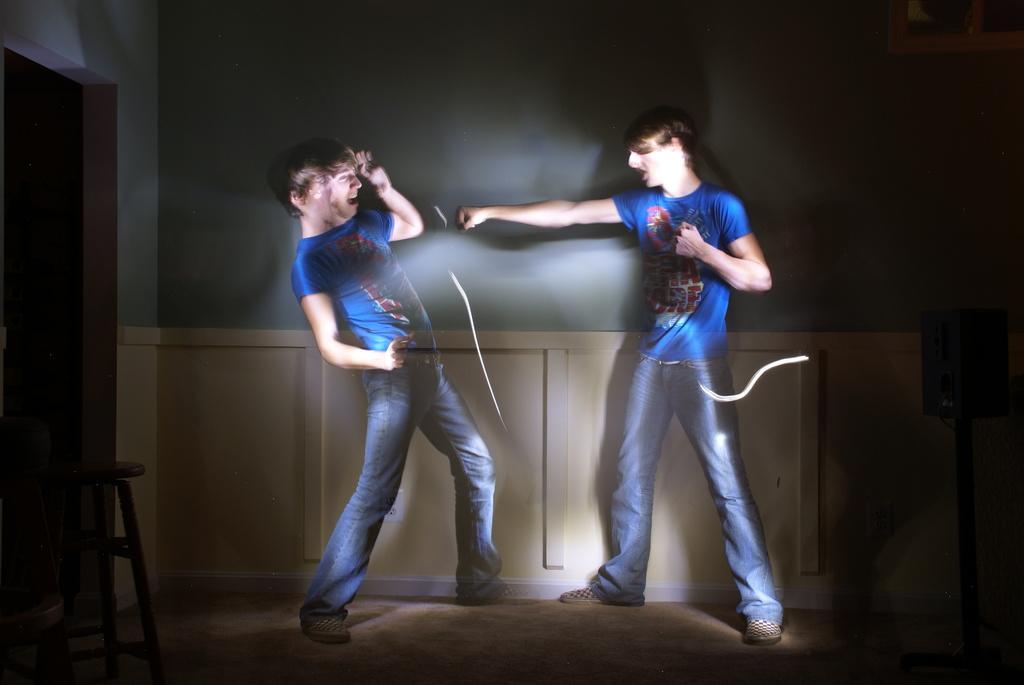Describe this image in one or two sentences. This is an animated picture we can see there are two people standing and on the left side of the people there is a stool. Behind the people there is a wall. 